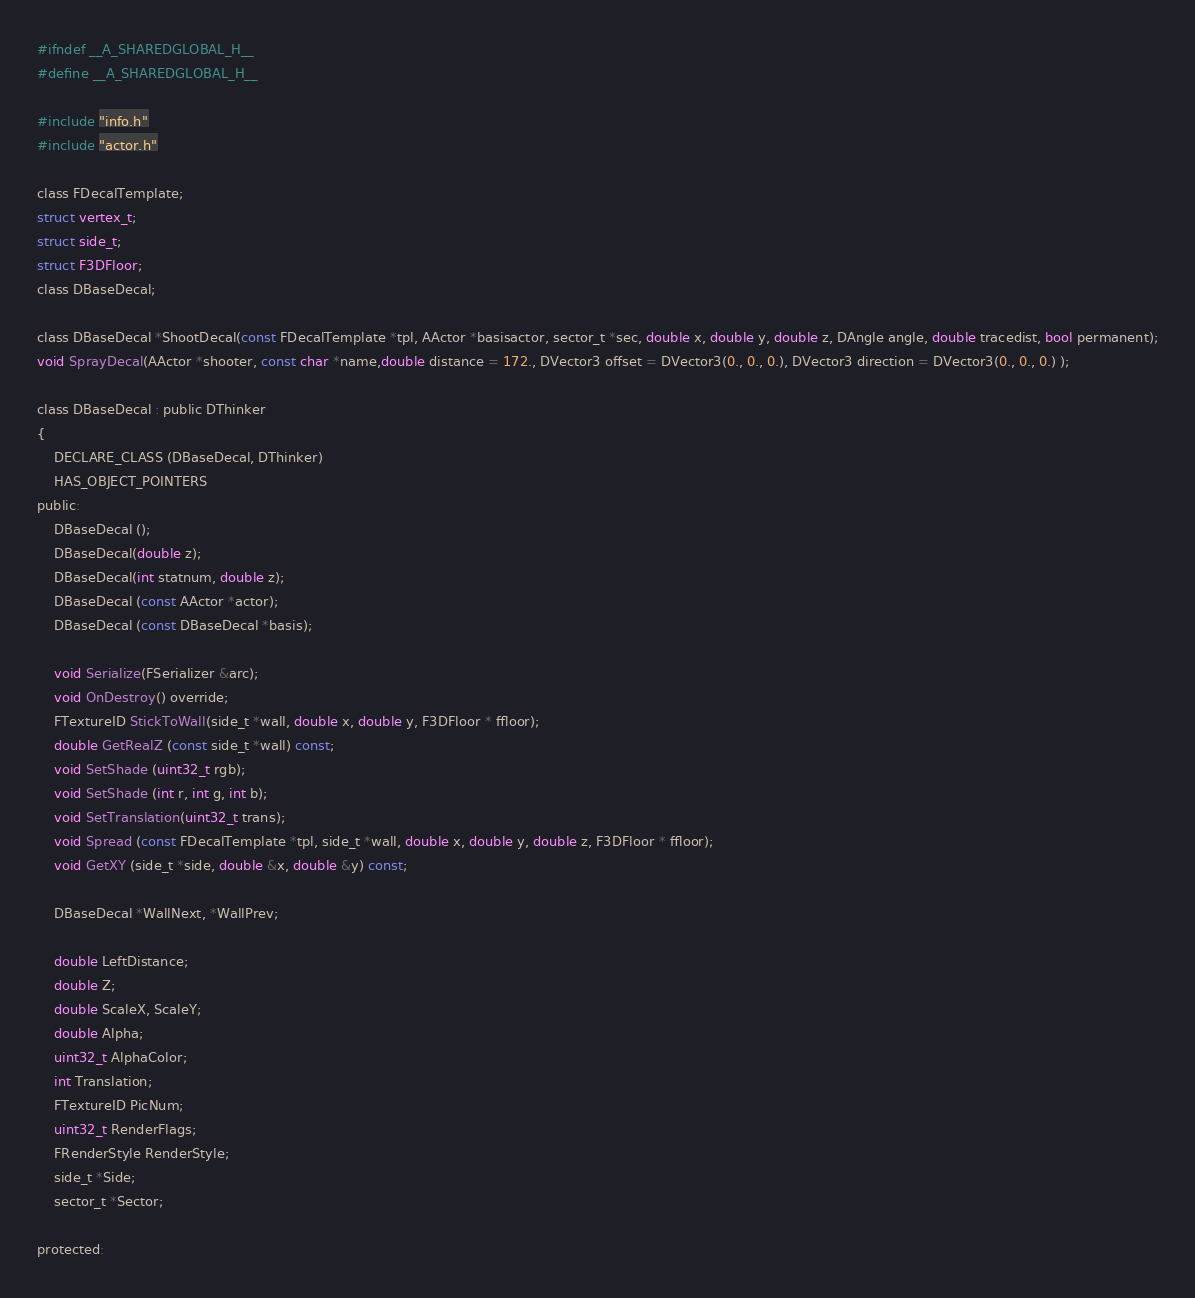<code> <loc_0><loc_0><loc_500><loc_500><_C_>#ifndef __A_SHAREDGLOBAL_H__
#define __A_SHAREDGLOBAL_H__

#include "info.h"
#include "actor.h"

class FDecalTemplate;
struct vertex_t;
struct side_t;
struct F3DFloor;
class DBaseDecal;

class DBaseDecal *ShootDecal(const FDecalTemplate *tpl, AActor *basisactor, sector_t *sec, double x, double y, double z, DAngle angle, double tracedist, bool permanent);
void SprayDecal(AActor *shooter, const char *name,double distance = 172., DVector3 offset = DVector3(0., 0., 0.), DVector3 direction = DVector3(0., 0., 0.) );

class DBaseDecal : public DThinker
{
	DECLARE_CLASS (DBaseDecal, DThinker)
	HAS_OBJECT_POINTERS
public:
	DBaseDecal ();
	DBaseDecal(double z);
	DBaseDecal(int statnum, double z);
	DBaseDecal (const AActor *actor);
	DBaseDecal (const DBaseDecal *basis);

	void Serialize(FSerializer &arc);
	void OnDestroy() override;
	FTextureID StickToWall(side_t *wall, double x, double y, F3DFloor * ffloor);
	double GetRealZ (const side_t *wall) const;
	void SetShade (uint32_t rgb);
	void SetShade (int r, int g, int b);
	void SetTranslation(uint32_t trans);
	void Spread (const FDecalTemplate *tpl, side_t *wall, double x, double y, double z, F3DFloor * ffloor);
	void GetXY (side_t *side, double &x, double &y) const;

	DBaseDecal *WallNext, *WallPrev;

	double LeftDistance;
	double Z;
	double ScaleX, ScaleY;
	double Alpha;
	uint32_t AlphaColor;
	int Translation;
	FTextureID PicNum;
	uint32_t RenderFlags;
	FRenderStyle RenderStyle;
	side_t *Side;
	sector_t *Sector;

protected:</code> 